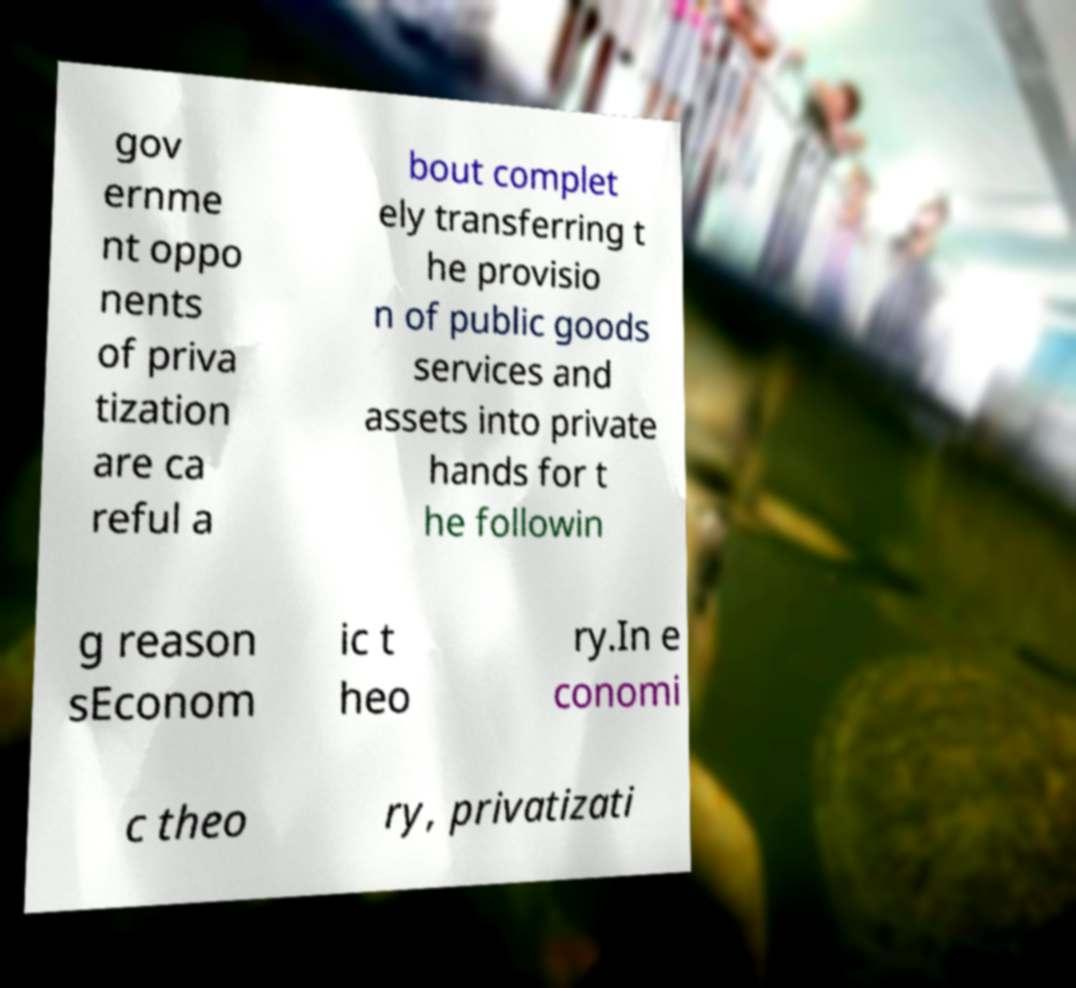For documentation purposes, I need the text within this image transcribed. Could you provide that? gov ernme nt oppo nents of priva tization are ca reful a bout complet ely transferring t he provisio n of public goods services and assets into private hands for t he followin g reason sEconom ic t heo ry.In e conomi c theo ry, privatizati 